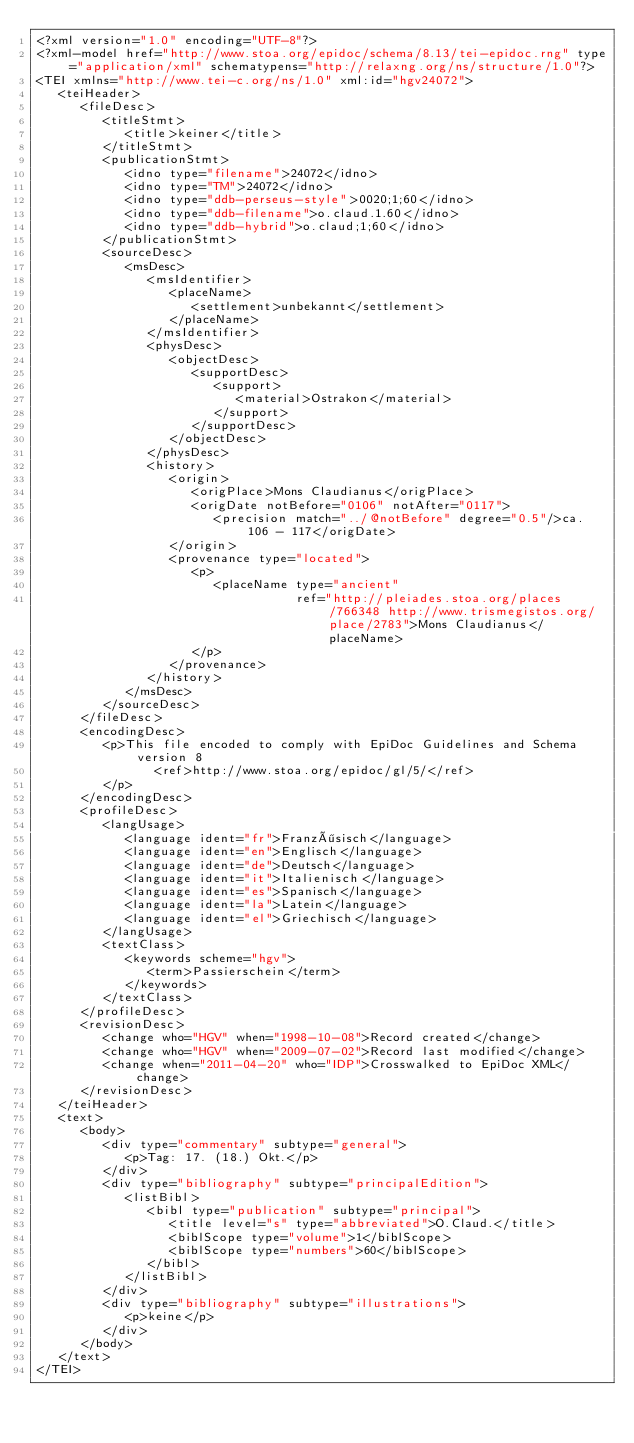Convert code to text. <code><loc_0><loc_0><loc_500><loc_500><_XML_><?xml version="1.0" encoding="UTF-8"?>
<?xml-model href="http://www.stoa.org/epidoc/schema/8.13/tei-epidoc.rng" type="application/xml" schematypens="http://relaxng.org/ns/structure/1.0"?>
<TEI xmlns="http://www.tei-c.org/ns/1.0" xml:id="hgv24072">
   <teiHeader>
      <fileDesc>
         <titleStmt>
            <title>keiner</title>
         </titleStmt>
         <publicationStmt>
            <idno type="filename">24072</idno>
            <idno type="TM">24072</idno>
            <idno type="ddb-perseus-style">0020;1;60</idno>
            <idno type="ddb-filename">o.claud.1.60</idno>
            <idno type="ddb-hybrid">o.claud;1;60</idno>
         </publicationStmt>
         <sourceDesc>
            <msDesc>
               <msIdentifier>
                  <placeName>
                     <settlement>unbekannt</settlement>
                  </placeName>
               </msIdentifier>
               <physDesc>
                  <objectDesc>
                     <supportDesc>
                        <support>
                           <material>Ostrakon</material>
                        </support>
                     </supportDesc>
                  </objectDesc>
               </physDesc>
               <history>
                  <origin>
                     <origPlace>Mons Claudianus</origPlace>
                     <origDate notBefore="0106" notAfter="0117">
                        <precision match="../@notBefore" degree="0.5"/>ca. 106 - 117</origDate>
                  </origin>
                  <provenance type="located">
                     <p>
                        <placeName type="ancient"
                                   ref="http://pleiades.stoa.org/places/766348 http://www.trismegistos.org/place/2783">Mons Claudianus</placeName>
                     </p>
                  </provenance>
               </history>
            </msDesc>
         </sourceDesc>
      </fileDesc>
      <encodingDesc>
         <p>This file encoded to comply with EpiDoc Guidelines and Schema version 8
                <ref>http://www.stoa.org/epidoc/gl/5/</ref>
         </p>
      </encodingDesc>
      <profileDesc>
         <langUsage>
            <language ident="fr">Französisch</language>
            <language ident="en">Englisch</language>
            <language ident="de">Deutsch</language>
            <language ident="it">Italienisch</language>
            <language ident="es">Spanisch</language>
            <language ident="la">Latein</language>
            <language ident="el">Griechisch</language>
         </langUsage>
         <textClass>
            <keywords scheme="hgv">
               <term>Passierschein</term>
            </keywords>
         </textClass>
      </profileDesc>
      <revisionDesc>
         <change who="HGV" when="1998-10-08">Record created</change>
         <change who="HGV" when="2009-07-02">Record last modified</change>
         <change when="2011-04-20" who="IDP">Crosswalked to EpiDoc XML</change>
      </revisionDesc>
   </teiHeader>
   <text>
      <body>
         <div type="commentary" subtype="general">
            <p>Tag: 17. (18.) Okt.</p>
         </div>
         <div type="bibliography" subtype="principalEdition">
            <listBibl>
               <bibl type="publication" subtype="principal">
                  <title level="s" type="abbreviated">O.Claud.</title>
                  <biblScope type="volume">1</biblScope>
                  <biblScope type="numbers">60</biblScope>
               </bibl>
            </listBibl>
         </div>
         <div type="bibliography" subtype="illustrations">
            <p>keine</p>
         </div>
      </body>
   </text>
</TEI>
</code> 